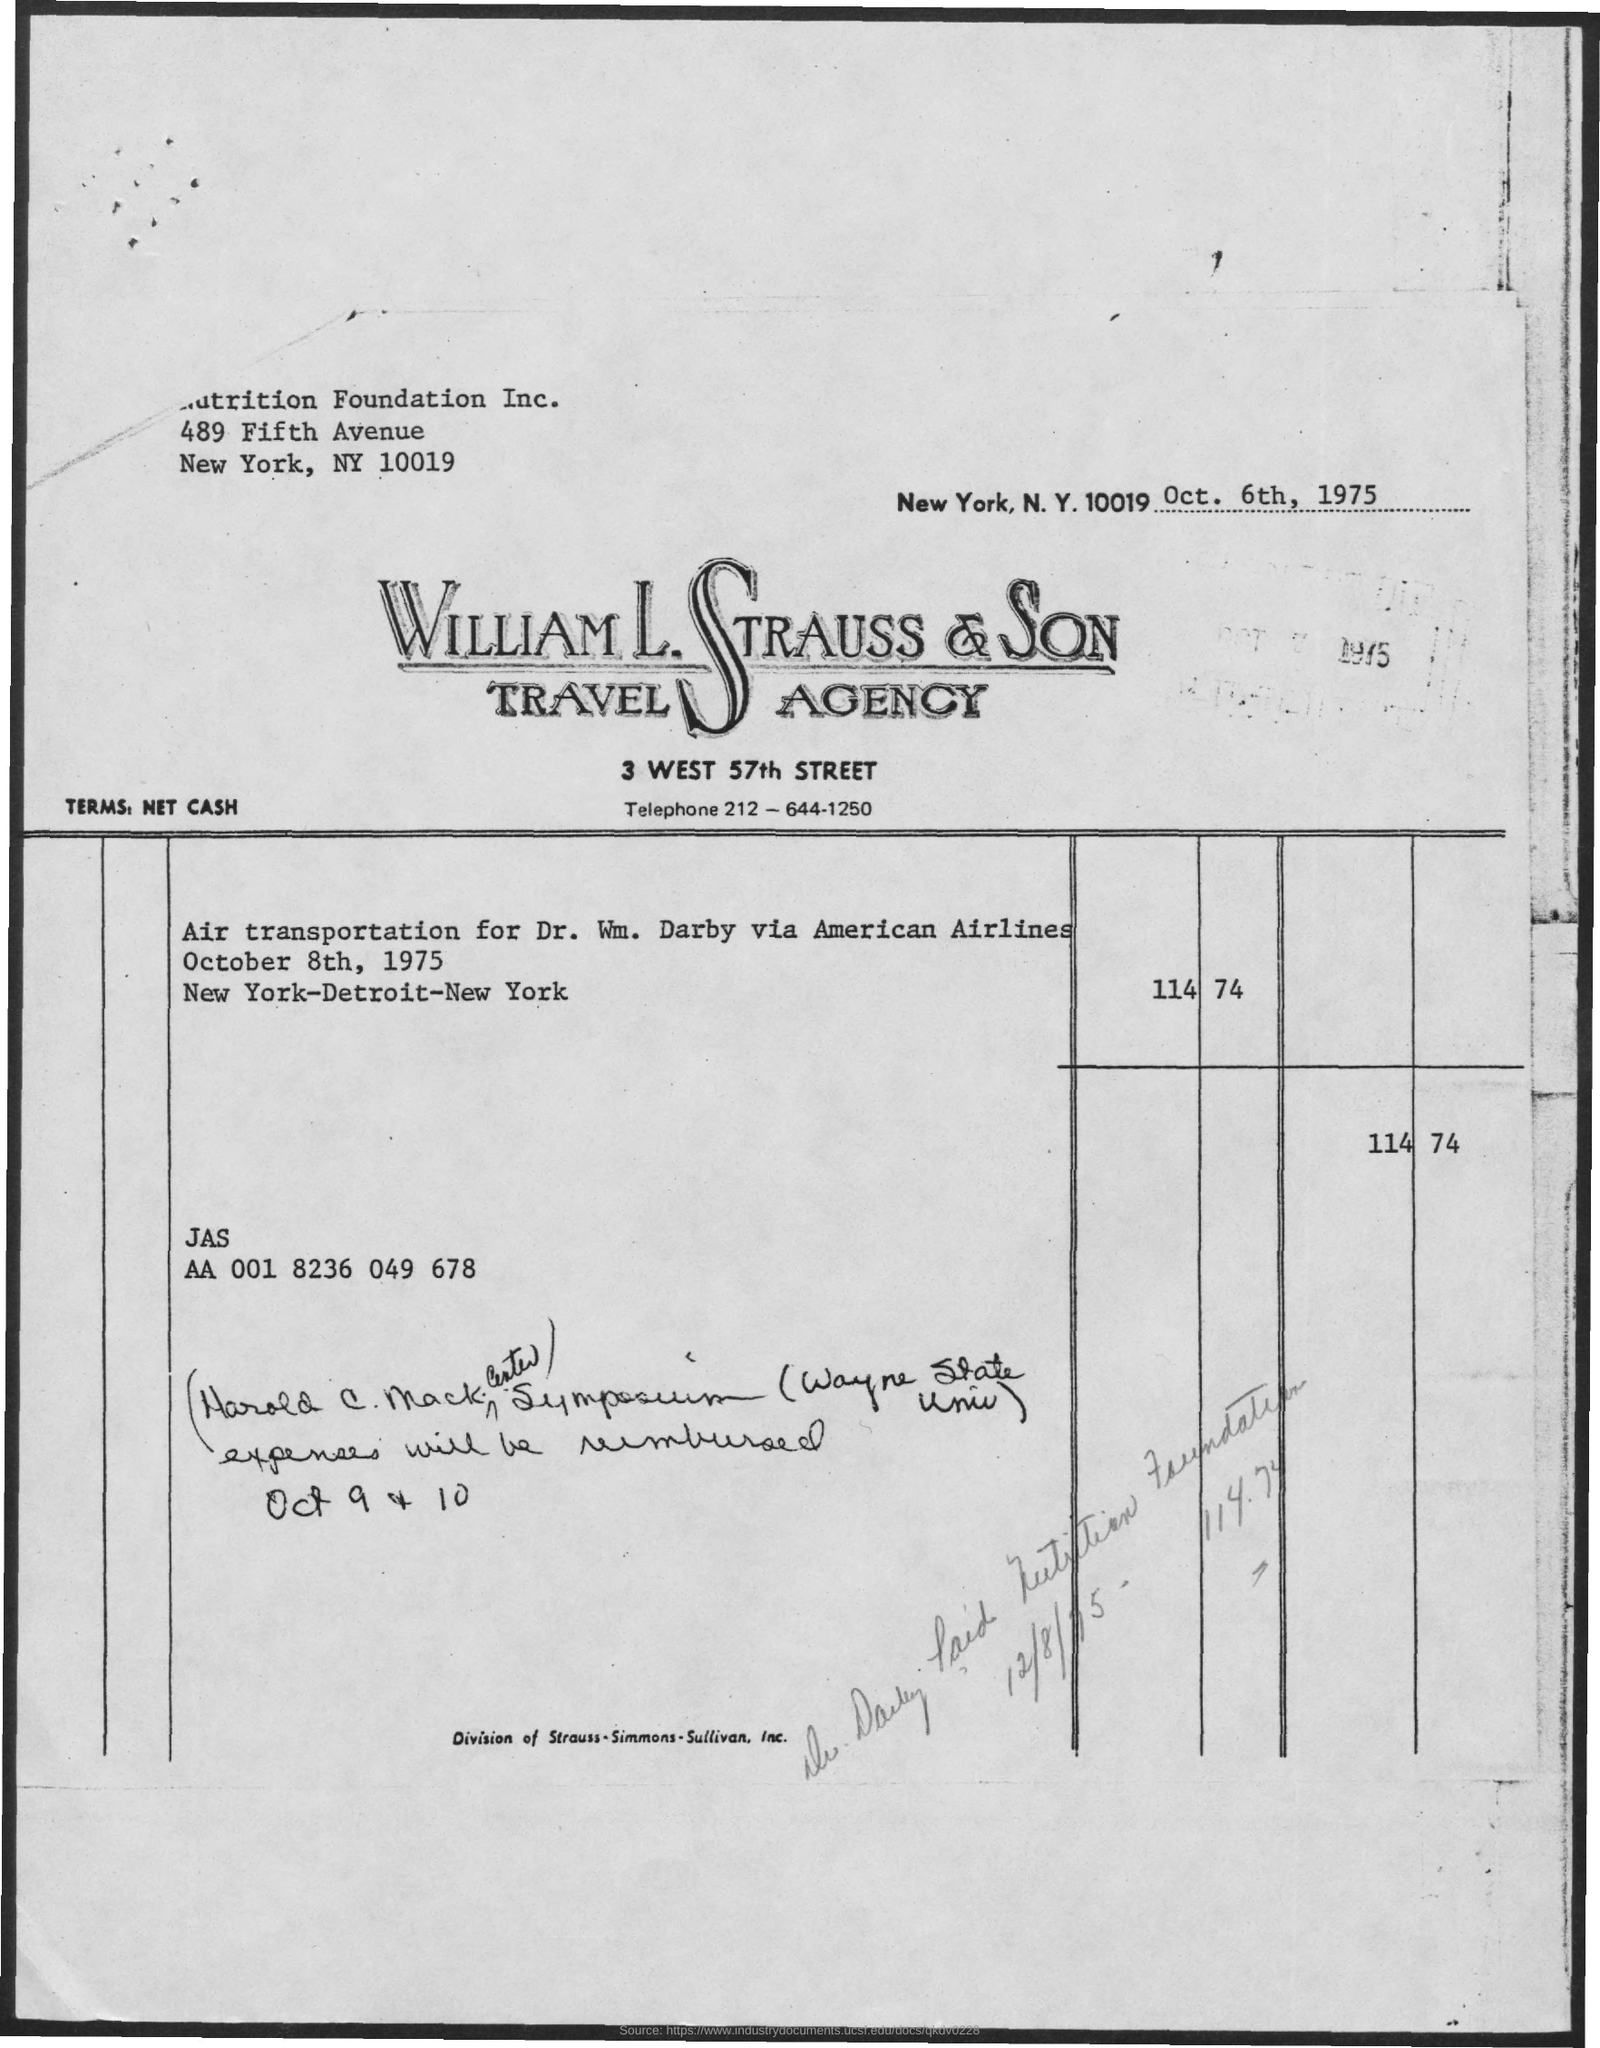What is the Zip code for NY ?
Provide a succinct answer. 10019. 